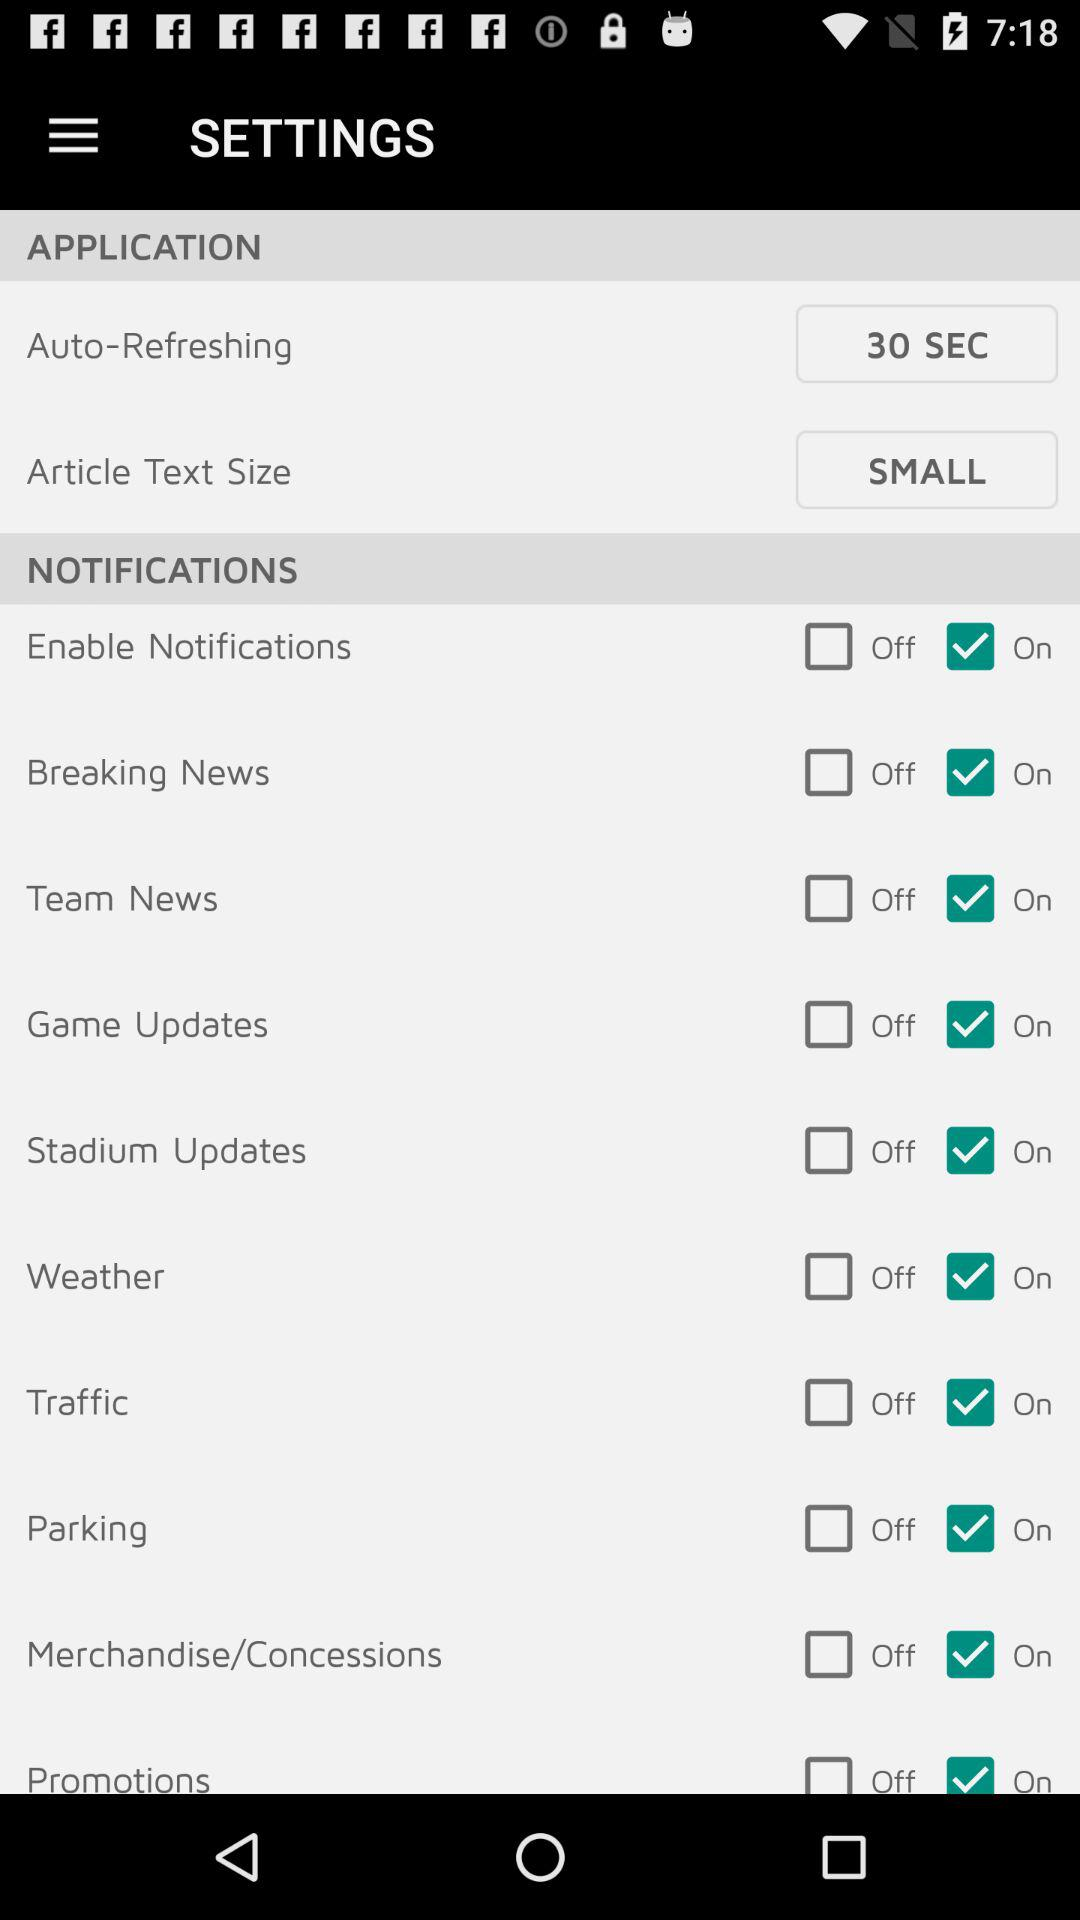How many options are available in "Auto-Refreshing"?
When the provided information is insufficient, respond with <no answer>. <no answer> 